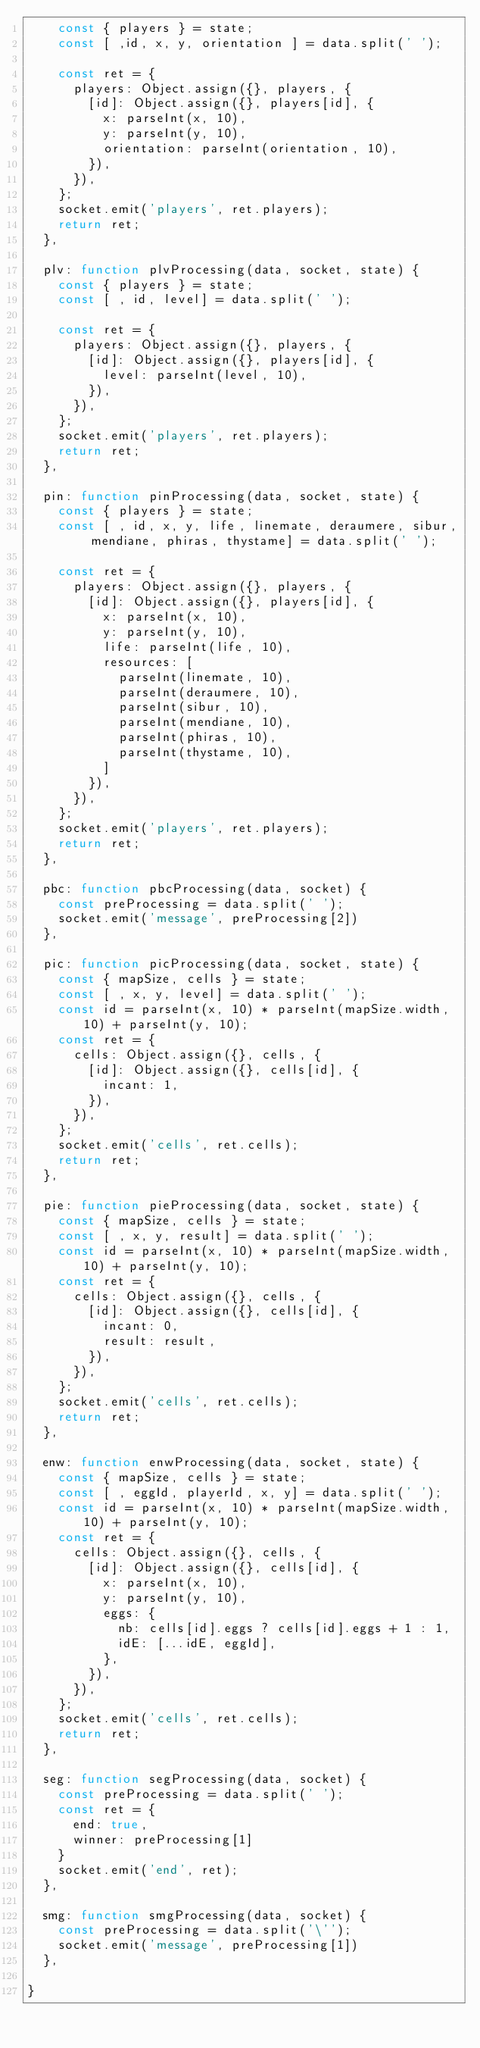<code> <loc_0><loc_0><loc_500><loc_500><_JavaScript_>    const { players } = state;
    const [ ,id, x, y, orientation ] = data.split(' ');

    const ret = {
      players: Object.assign({}, players, {
        [id]: Object.assign({}, players[id], {
          x: parseInt(x, 10),
          y: parseInt(y, 10),
          orientation: parseInt(orientation, 10),
        }),
      }),
    };
    socket.emit('players', ret.players);
    return ret;
  },

  plv: function plvProcessing(data, socket, state) {
    const { players } = state;
    const [ , id, level] = data.split(' ');

    const ret = {
      players: Object.assign({}, players, {
        [id]: Object.assign({}, players[id], {
          level: parseInt(level, 10),
        }),
      }),
    };
    socket.emit('players', ret.players);
    return ret;
  },

  pin: function pinProcessing(data, socket, state) {
    const { players } = state;
    const [ , id, x, y, life, linemate, deraumere, sibur, mendiane, phiras, thystame] = data.split(' ');

    const ret = {
      players: Object.assign({}, players, {
        [id]: Object.assign({}, players[id], {
          x: parseInt(x, 10),
          y: parseInt(y, 10),
          life: parseInt(life, 10),
          resources: [
            parseInt(linemate, 10),
            parseInt(deraumere, 10),
            parseInt(sibur, 10),
            parseInt(mendiane, 10),
            parseInt(phiras, 10),
            parseInt(thystame, 10),
          ]
        }),
      }),
    };
    socket.emit('players', ret.players);
    return ret;
  },

  pbc: function pbcProcessing(data, socket) {
    const preProcessing = data.split(' ');
    socket.emit('message', preProcessing[2])
  },

  pic: function picProcessing(data, socket, state) {
    const { mapSize, cells } = state;
    const [ , x, y, level] = data.split(' ');
    const id = parseInt(x, 10) * parseInt(mapSize.width, 10) + parseInt(y, 10);
    const ret = {
      cells: Object.assign({}, cells, {
        [id]: Object.assign({}, cells[id], {
          incant: 1,
        }),
      }),
    };
    socket.emit('cells', ret.cells);
    return ret;
  },

  pie: function pieProcessing(data, socket, state) {
    const { mapSize, cells } = state;
    const [ , x, y, result] = data.split(' ');
    const id = parseInt(x, 10) * parseInt(mapSize.width, 10) + parseInt(y, 10);
    const ret = {
      cells: Object.assign({}, cells, {
        [id]: Object.assign({}, cells[id], {
          incant: 0,
          result: result,
        }),
      }),
    };
    socket.emit('cells', ret.cells);
    return ret;
  },

  enw: function enwProcessing(data, socket, state) {
    const { mapSize, cells } = state;
    const [ , eggId, playerId, x, y] = data.split(' ');
    const id = parseInt(x, 10) * parseInt(mapSize.width, 10) + parseInt(y, 10);
    const ret = {
      cells: Object.assign({}, cells, {
        [id]: Object.assign({}, cells[id], {
          x: parseInt(x, 10),
          y: parseInt(y, 10),
          eggs: {
            nb: cells[id].eggs ? cells[id].eggs + 1 : 1,
            idE: [...idE, eggId],
          },
        }),
      }),
    };
    socket.emit('cells', ret.cells);
    return ret;
  },

  seg: function segProcessing(data, socket) {
    const preProcessing = data.split(' ');
    const ret = {
      end: true,
      winner: preProcessing[1]
    }
    socket.emit('end', ret);
  },

  smg: function smgProcessing(data, socket) {
    const preProcessing = data.split('\'');
    socket.emit('message', preProcessing[1])
  },

}
</code> 